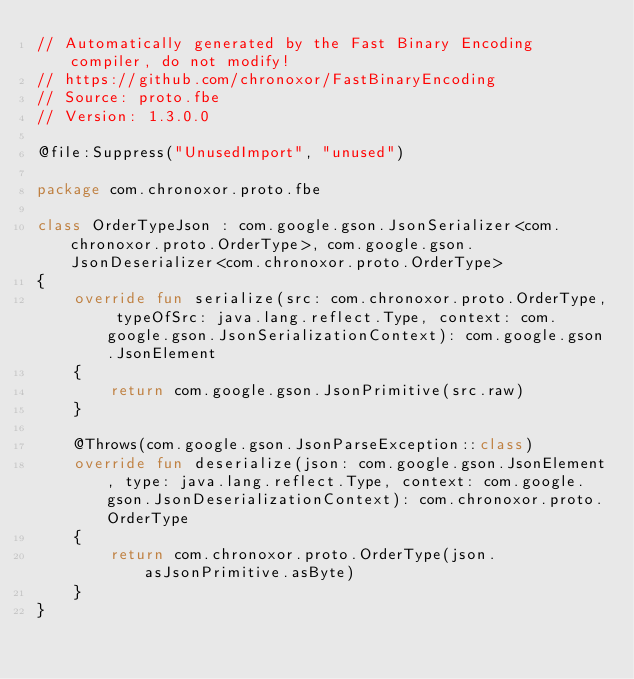Convert code to text. <code><loc_0><loc_0><loc_500><loc_500><_Kotlin_>// Automatically generated by the Fast Binary Encoding compiler, do not modify!
// https://github.com/chronoxor/FastBinaryEncoding
// Source: proto.fbe
// Version: 1.3.0.0

@file:Suppress("UnusedImport", "unused")

package com.chronoxor.proto.fbe

class OrderTypeJson : com.google.gson.JsonSerializer<com.chronoxor.proto.OrderType>, com.google.gson.JsonDeserializer<com.chronoxor.proto.OrderType>
{
    override fun serialize(src: com.chronoxor.proto.OrderType, typeOfSrc: java.lang.reflect.Type, context: com.google.gson.JsonSerializationContext): com.google.gson.JsonElement
    {
        return com.google.gson.JsonPrimitive(src.raw)
    }

    @Throws(com.google.gson.JsonParseException::class)
    override fun deserialize(json: com.google.gson.JsonElement, type: java.lang.reflect.Type, context: com.google.gson.JsonDeserializationContext): com.chronoxor.proto.OrderType
    {
        return com.chronoxor.proto.OrderType(json.asJsonPrimitive.asByte)
    }
}
</code> 